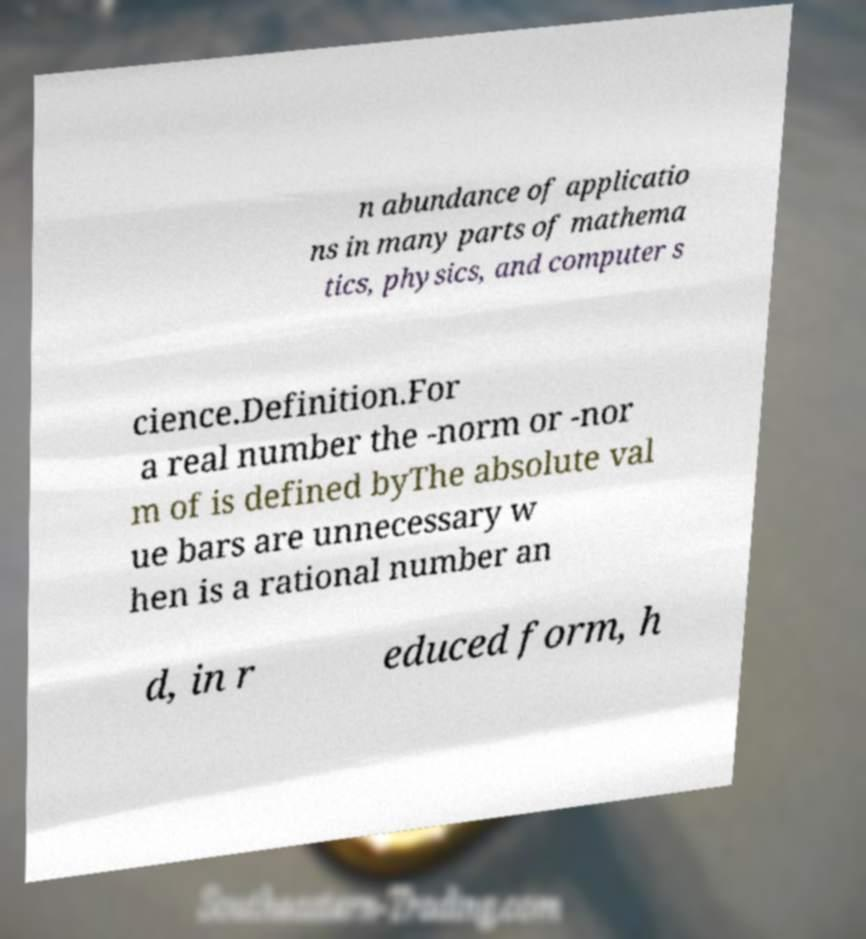There's text embedded in this image that I need extracted. Can you transcribe it verbatim? n abundance of applicatio ns in many parts of mathema tics, physics, and computer s cience.Definition.For a real number the -norm or -nor m of is defined byThe absolute val ue bars are unnecessary w hen is a rational number an d, in r educed form, h 